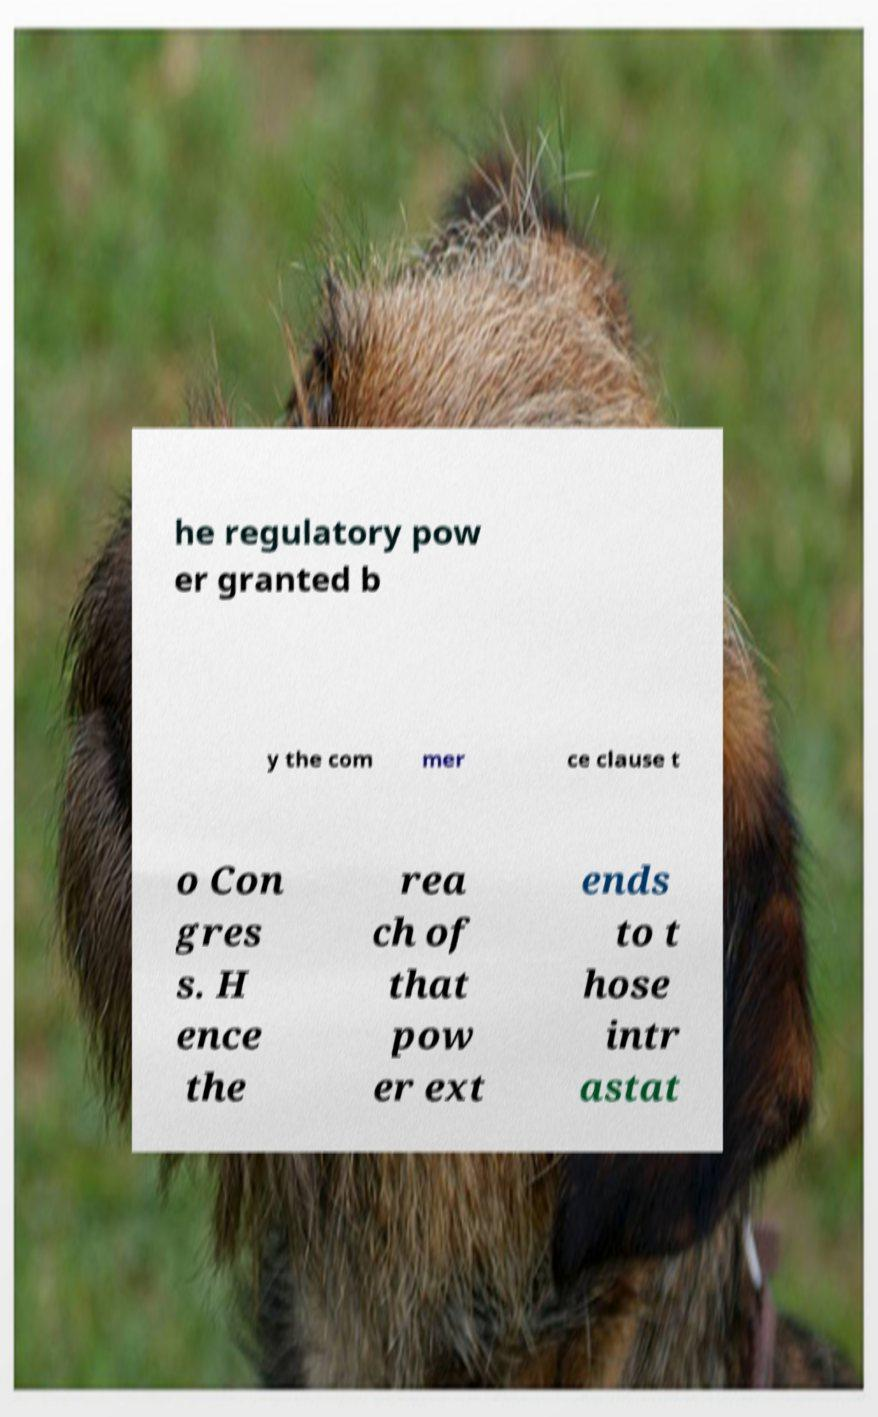There's text embedded in this image that I need extracted. Can you transcribe it verbatim? he regulatory pow er granted b y the com mer ce clause t o Con gres s. H ence the rea ch of that pow er ext ends to t hose intr astat 